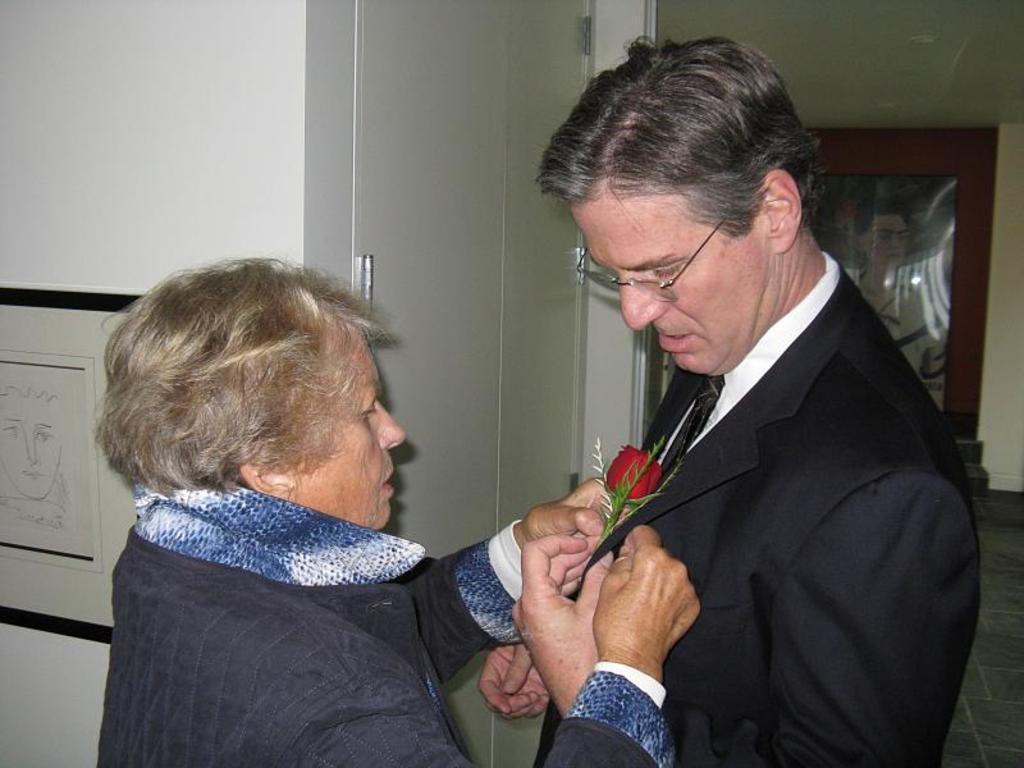Please provide a concise description of this image. In the center of the image we can see two persons are standing and they are in different costumes. Among them, we can see one person is holding a flower and the other person is wearing glasses. In the background there is a wall, door, photo frames and a few other objects. 